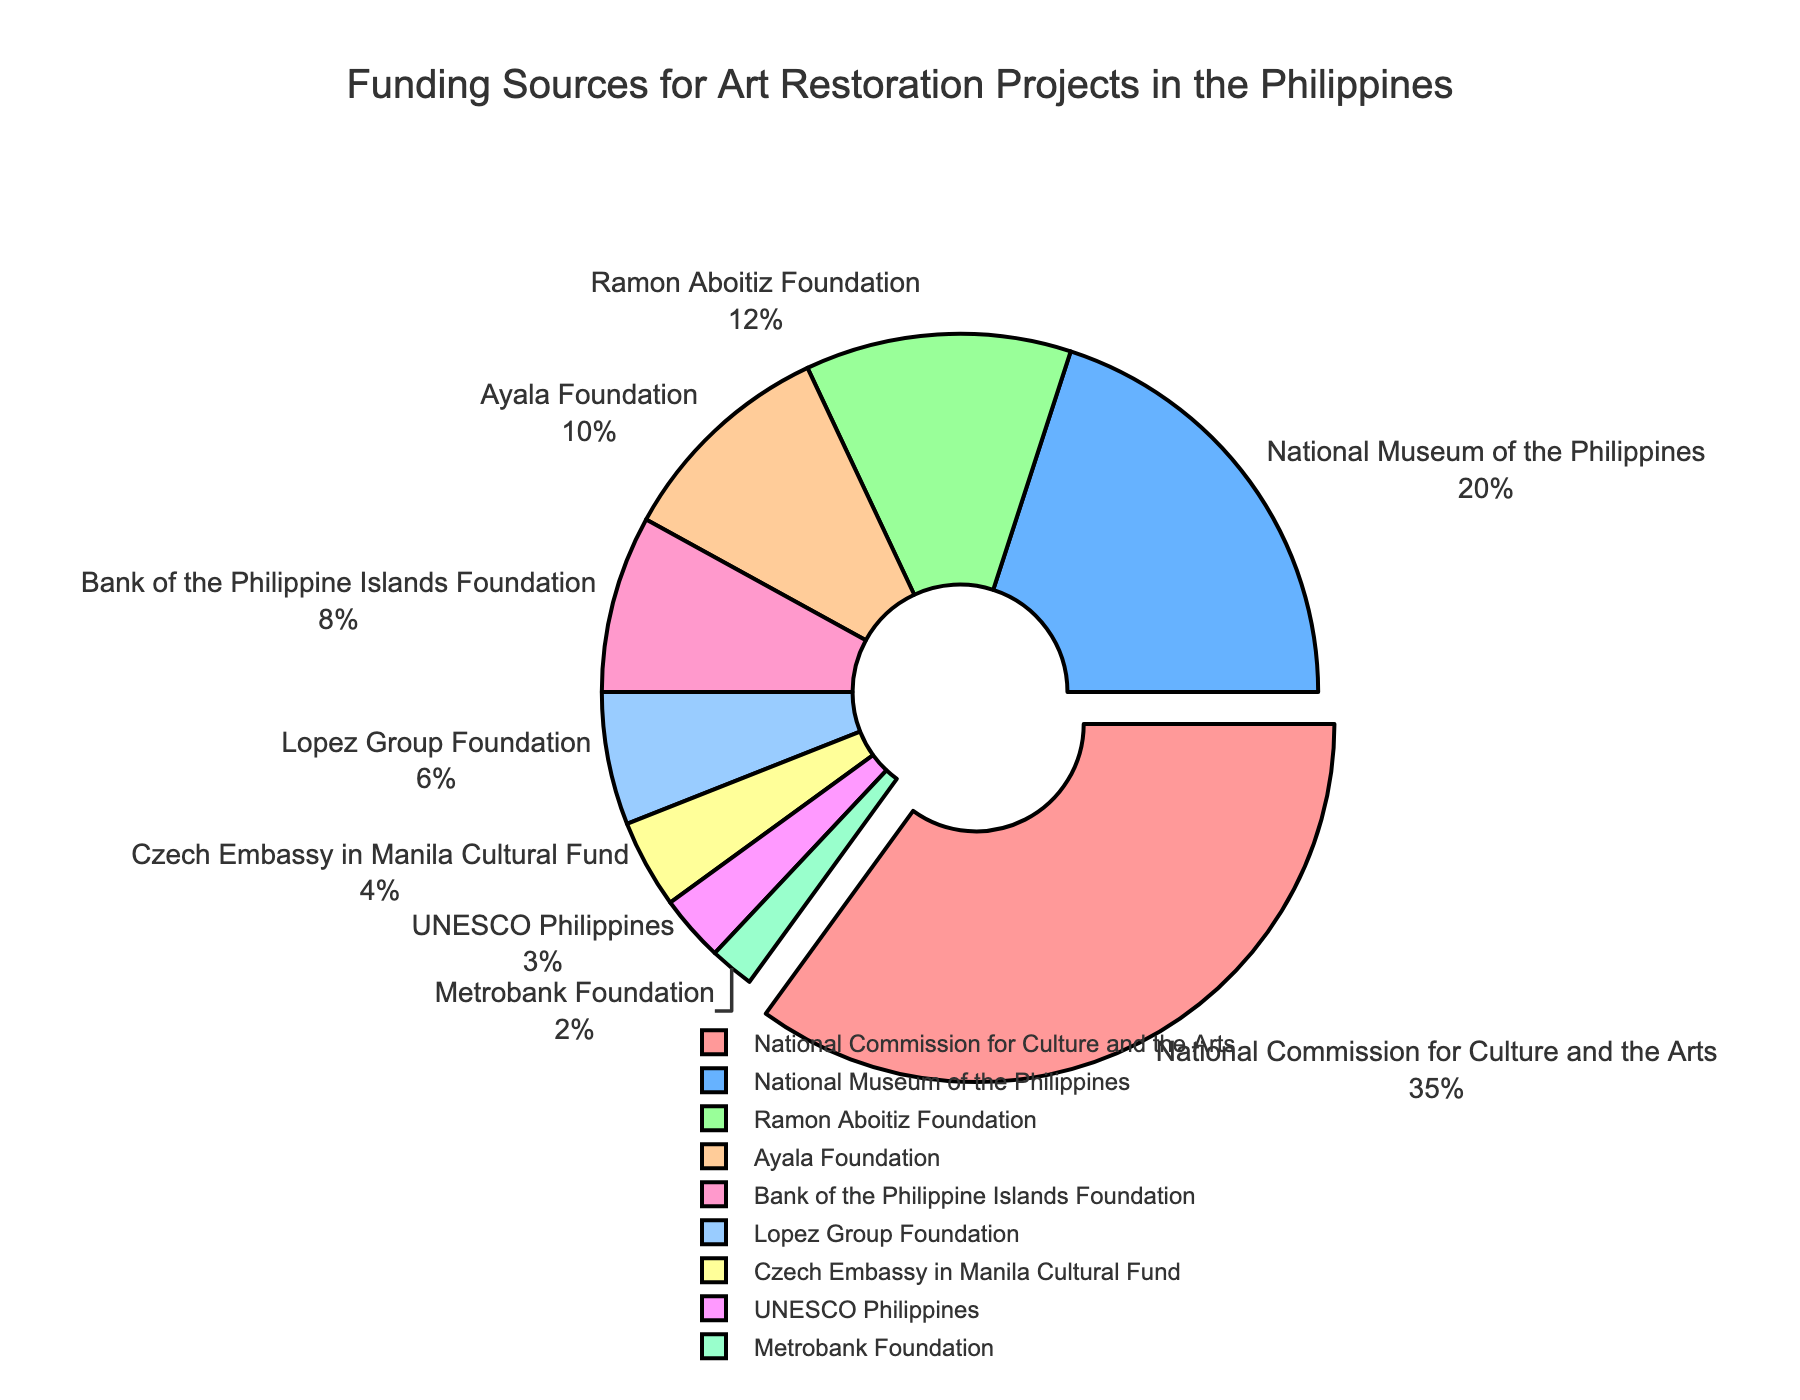Which funding source contributes the highest percentage? The pie chart shows that the National Commission for Culture and the Arts has the largest slice which also stands out slightly due to it being pulled out. It contributes 35%.
Answer: National Commission for Culture and the Arts Which funding sources contribute less than 5% each? From analyzing the pie chart, the sources that contribute less than 5% are the Czech Embassy in Manila Cultural Fund, UNESCO Philippines, and Metrobank Foundation with 4%, 3%, and 2% respectively.
Answer: Czech Embassy in Manila Cultural Fund, UNESCO Philippines, and Metrobank Foundation What is the combined percentage contribution of Ramon Aboitiz Foundation and Ayala Foundation? The Ramon Aboitiz Foundation contributes 12% and the Ayala Foundation contributes 10%. Combining these percentages: 12% + 10% = 22%.
Answer: 22% What percentage greater is the contribution of the National Museum of the Philippines than that of the Bank of the Philippine Islands Foundation? The National Museum of the Philippines contributes 20%, and the Bank of the Philippine Islands Foundation contributes 8%. The difference is 20% - 8% = 12%.
Answer: 12% Which funding source is represented by the light yellow color? The light yellow color in the pie chart corresponds to the Czech Embassy in Manila Cultural Fund, which contributes 4%.
Answer: Czech Embassy in Manila Cultural Fund Among private foundations, which one contributes the least percentage? Among the private foundations, the Metrobank Foundation contributes the least, with a contribution of 2%.
Answer: Metrobank Foundation How many funding sources contribute exactly 10% or more? By reviewing the chart, the sources that contribute 10% or more are the National Commission for Culture and the Arts (35%), the National Museum of the Philippines (20%), the Ramon Aboitiz Foundation (12%), and the Ayala Foundation (10%). This totals to four funding sources.
Answer: Four What is the total percentage contribution of all funding sources except the National Commission for Culture and the Arts? The National Commission for Culture and the Arts contributes 35%. Adding up all other contributions: 20% + 12% + 10% + 8% + 6% + 4% + 3% + 2% = 65%.
Answer: 65% Which funding source is highlighted by being slightly pulled out from the others? The segment that is slightly pulled out indicates the funding source which is the National Commission for Culture and the Arts.
Answer: National Commission for Culture and the Arts 